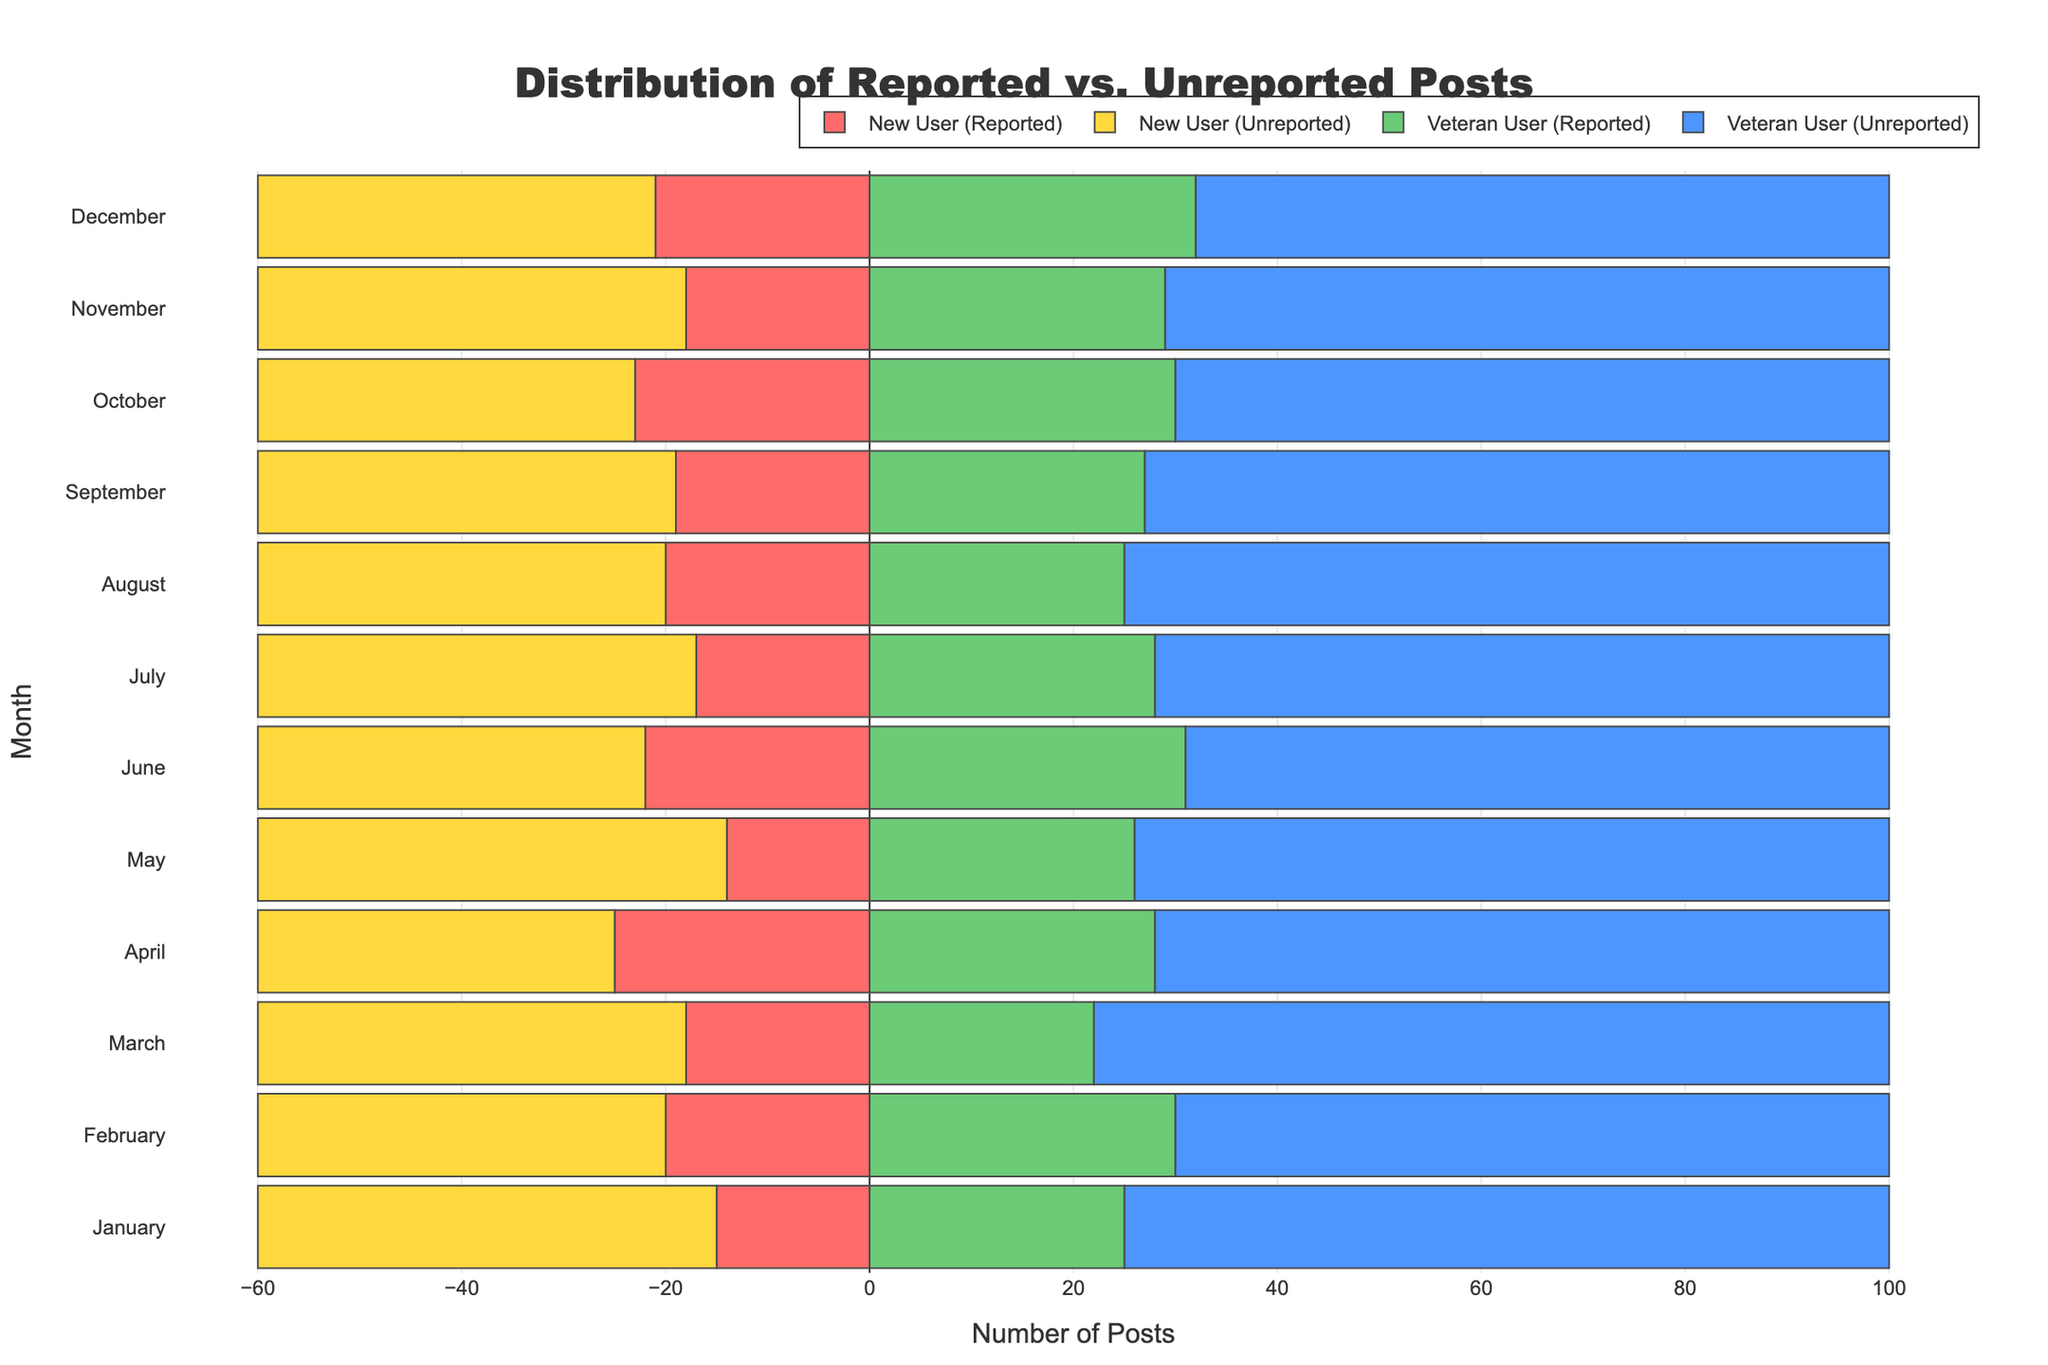What month had the highest number of reported posts from veteran users? Look for the bar representing reported posts for veteran users that extends the furthest to the right.
Answer: December Which user type reported the fewest posts in May? Compare the length of the bars representing reported posts for both new and veteran users in May. The bar representing new users is shorter.
Answer: New Users What is the total number of posts (reported and unreported) contributed by new users in July? Add the lengths of the bars representing reported and unreported posts for new users in July. The lengths are 17 (reported) and 43 (unreported). Summing these gives 17 + 43.
Answer: 60 By how much do veteran users' reported posts exceed new users' reported posts in November? Subtract the number of reported posts by new users from that of veteran users in November. Veteran users reported 29 posts while new users reported 18 posts. So, 29 - 18.
Answer: 11 In which month did new users have the highest number of unreported posts? Look at the month with the longest bar for unreported posts among new users. The most extended bar for new users' unreported posts occurs in January.
Answer: January How did the number of reported posts by new users change from February to March? Compare the lengths of the bars representing reported posts for new users in February and March. In February, new users reported 20 posts, and in March, they reported 18 posts. The change is 18 - 20.
Answer: -2 How many more unreported posts did veteran users have compared to new users in April? Subtract the number of unreported posts by new users from that of veteran users in April. Veteran users had 72 unreported posts, and new users had 35 unreported posts. So, 72 - 35.
Answer: 37 Which user type had more reported posts in October? Compare the lengths of the bars representing reported posts for new and veteran users in October. The bar for veteran users is longer.
Answer: Veteran Users What is the average number of unreported posts by veteran users over the 12 months? Sum the number of unreported posts by veteran users for each month and divide by 12. The numbers are: 75, 70, 78, 72, 74, 69, 72, 75, 73, 70, 71, 68. Summing these gives 867, and dividing by 12 gives 867 / 12.
Answer: 72.25 